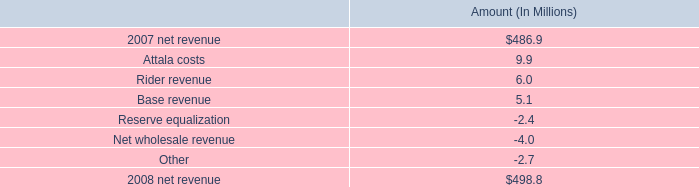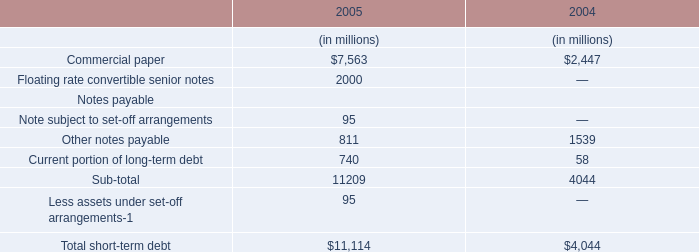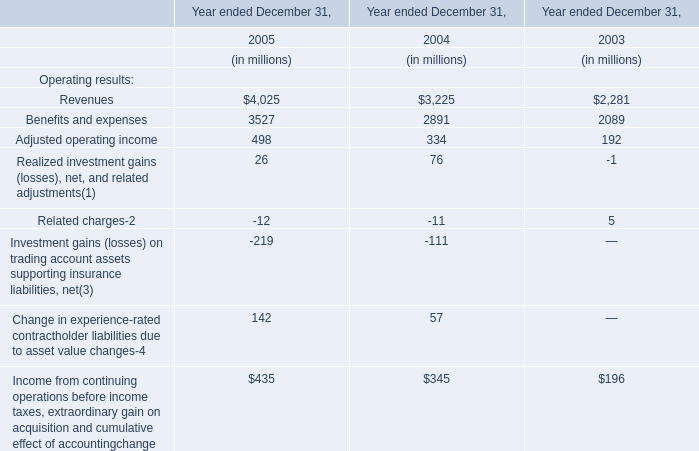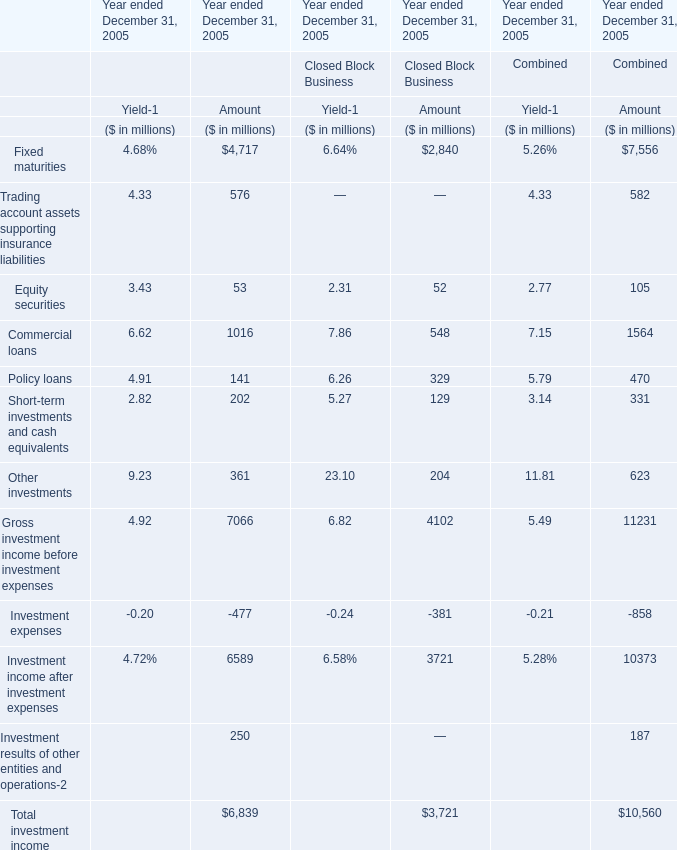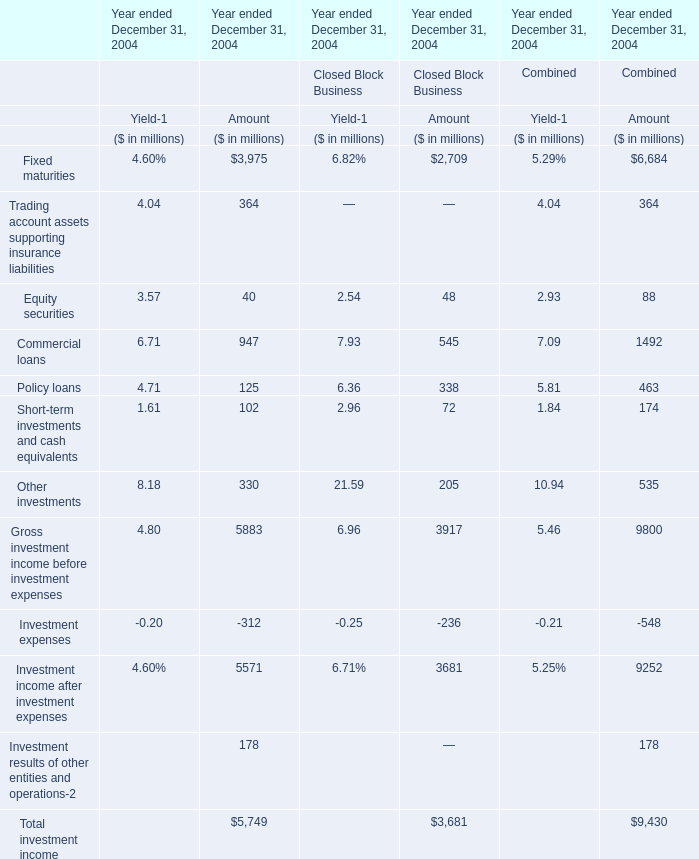what percent of the change in net revenue was due to rider revenue? 
Computations: (6 / (498.8 - 486.9))
Answer: 0.5042. 